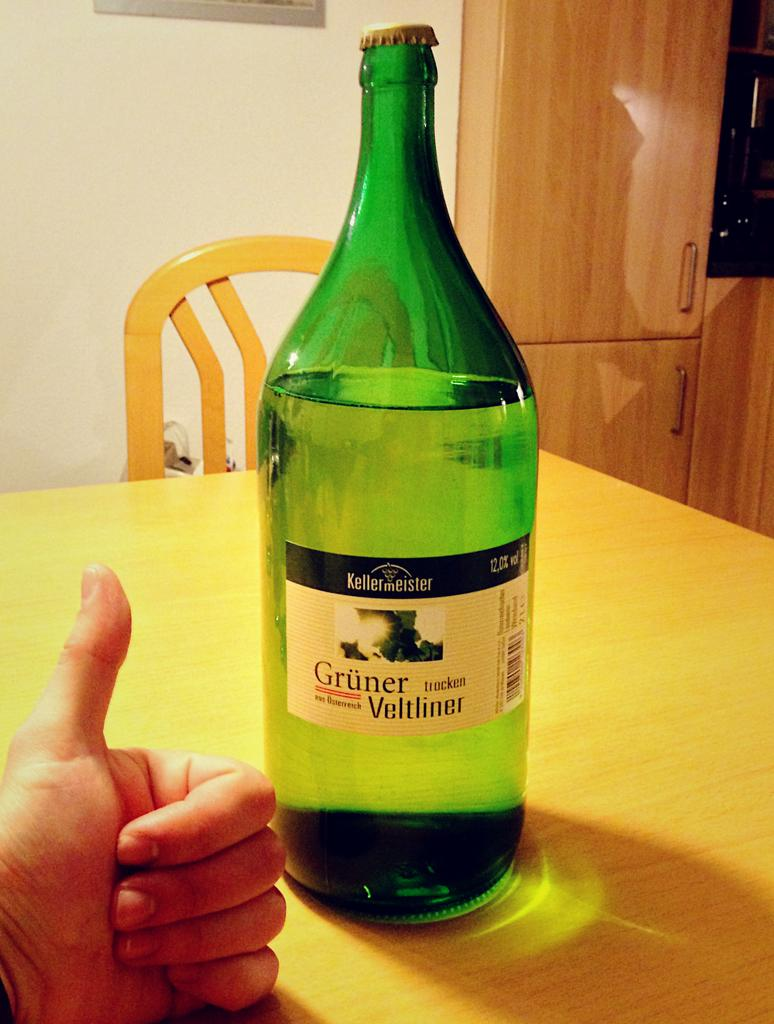Provide a one-sentence caption for the provided image. A green bottle with Gruner Veltliner written on the label. 